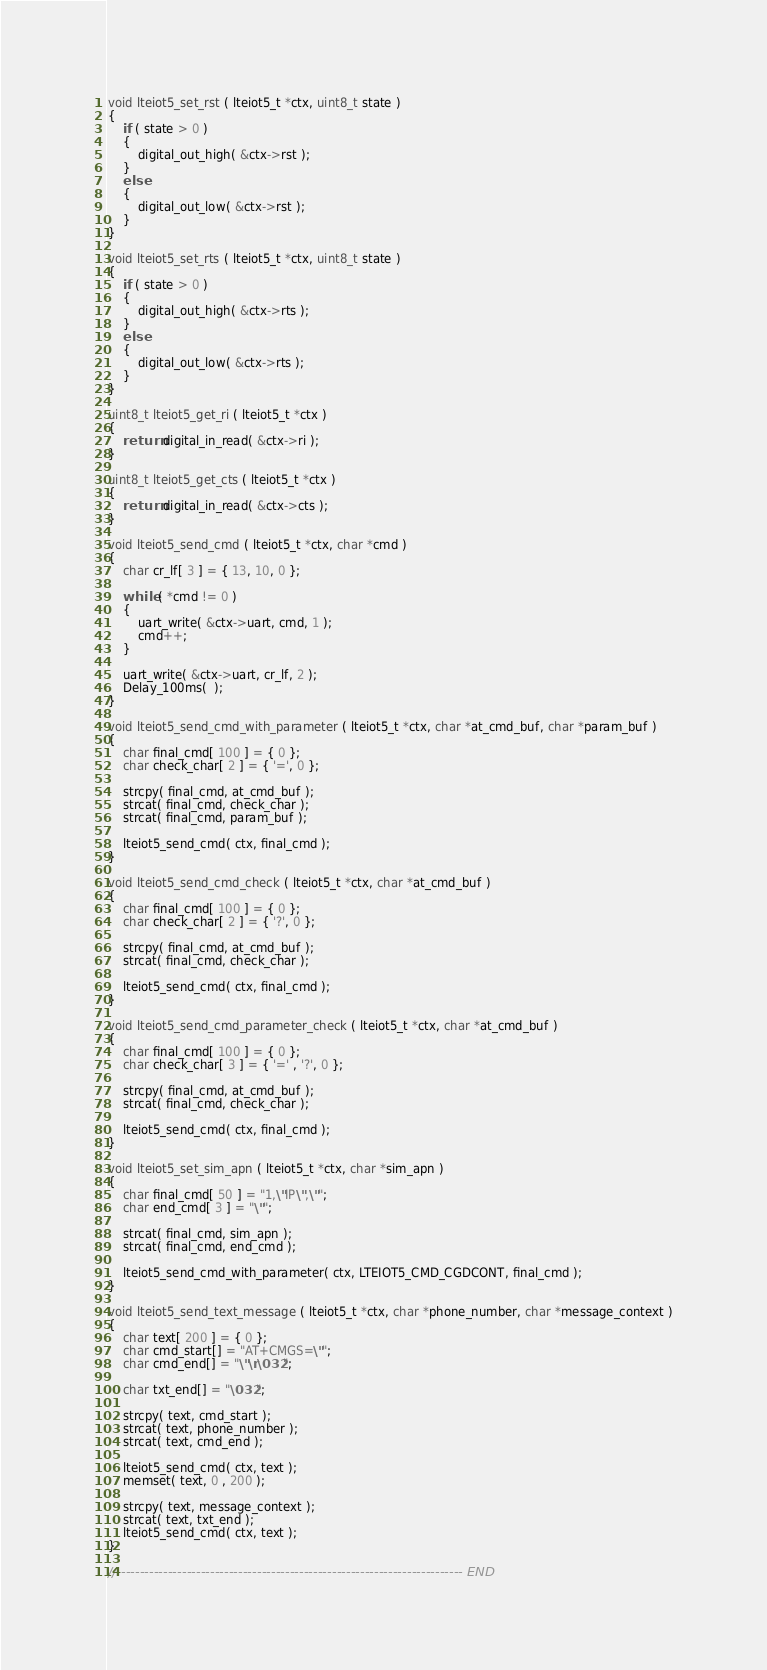<code> <loc_0><loc_0><loc_500><loc_500><_C_>void lteiot5_set_rst ( lteiot5_t *ctx, uint8_t state )
{
    if ( state > 0 )
    {
        digital_out_high( &ctx->rst );
    }
    else
    {
        digital_out_low( &ctx->rst );
    }
}

void lteiot5_set_rts ( lteiot5_t *ctx, uint8_t state )
{
    if ( state > 0 )
    {
        digital_out_high( &ctx->rts );
    }
    else
    {
        digital_out_low( &ctx->rts );
    }
}

uint8_t lteiot5_get_ri ( lteiot5_t *ctx )
{
    return digital_in_read( &ctx->ri );
}

uint8_t lteiot5_get_cts ( lteiot5_t *ctx )
{
    return digital_in_read( &ctx->cts );
}

void lteiot5_send_cmd ( lteiot5_t *ctx, char *cmd )
{
    char cr_lf[ 3 ] = { 13, 10, 0 };
    
    while ( *cmd != 0 )
    {
        uart_write( &ctx->uart, cmd, 1 );
        cmd++;
    }
    
    uart_write( &ctx->uart, cr_lf, 2 );
    Delay_100ms(  );
}

void lteiot5_send_cmd_with_parameter ( lteiot5_t *ctx, char *at_cmd_buf, char *param_buf )
{
    char final_cmd[ 100 ] = { 0 };
    char check_char[ 2 ] = { '=', 0 };
    
    strcpy( final_cmd, at_cmd_buf );
    strcat( final_cmd, check_char );
    strcat( final_cmd, param_buf );
    
    lteiot5_send_cmd( ctx, final_cmd );
}

void lteiot5_send_cmd_check ( lteiot5_t *ctx, char *at_cmd_buf )
{
    char final_cmd[ 100 ] = { 0 };
    char check_char[ 2 ] = { '?', 0 };
    
    strcpy( final_cmd, at_cmd_buf );
    strcat( final_cmd, check_char );
    
    lteiot5_send_cmd( ctx, final_cmd );
}

void lteiot5_send_cmd_parameter_check ( lteiot5_t *ctx, char *at_cmd_buf )
{
    char final_cmd[ 100 ] = { 0 };
    char check_char[ 3 ] = { '=' , '?', 0 };
    
    strcpy( final_cmd, at_cmd_buf );
    strcat( final_cmd, check_char );
    
    lteiot5_send_cmd( ctx, final_cmd );
}

void lteiot5_set_sim_apn ( lteiot5_t *ctx, char *sim_apn )
{
    char final_cmd[ 50 ] = "1,\"IP\",\"";
    char end_cmd[ 3 ] = "\"";
    
    strcat( final_cmd, sim_apn );
    strcat( final_cmd, end_cmd );
    
    lteiot5_send_cmd_with_parameter( ctx, LTEIOT5_CMD_CGDCONT, final_cmd );
}

void lteiot5_send_text_message ( lteiot5_t *ctx, char *phone_number, char *message_context )
{
    char text[ 200 ] = { 0 };
    char cmd_start[] = "AT+CMGS=\"";
    char cmd_end[] = "\"\r\032";
    
    char txt_end[] = "\032";
    
    strcpy( text, cmd_start );
    strcat( text, phone_number );
    strcat( text, cmd_end );
    
    lteiot5_send_cmd( ctx, text );
    memset( text, 0 , 200 );
    
    strcpy( text, message_context );
    strcat( text, txt_end );
    lteiot5_send_cmd( ctx, text );
}

// ------------------------------------------------------------------------- END
</code> 